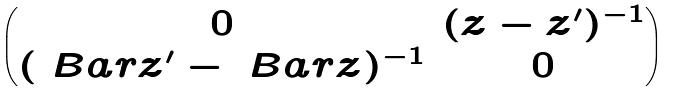Convert formula to latex. <formula><loc_0><loc_0><loc_500><loc_500>\begin{pmatrix} 0 & ( z - z ^ { \prime } ) ^ { - 1 } \\ ( \ B a r { z } ^ { \prime } - \ B a r { z } ) ^ { - 1 } & 0 \end{pmatrix}</formula> 